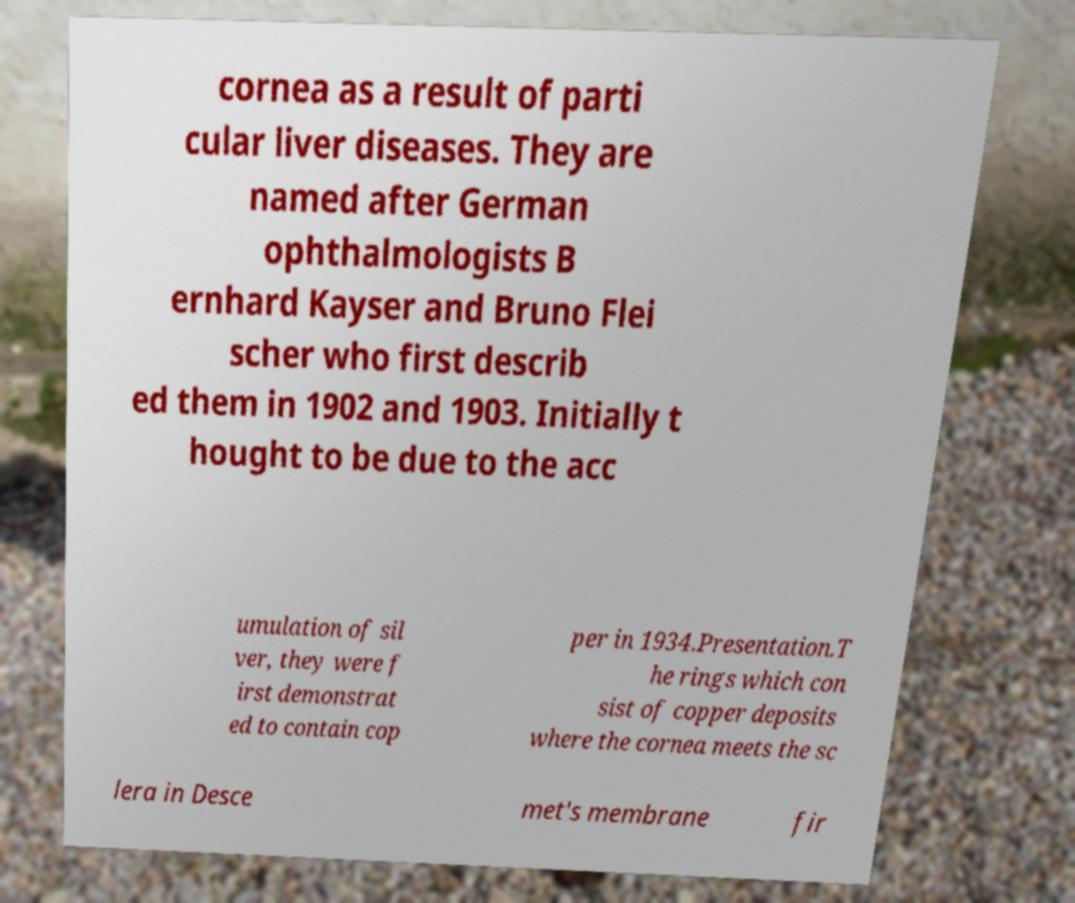Could you assist in decoding the text presented in this image and type it out clearly? cornea as a result of parti cular liver diseases. They are named after German ophthalmologists B ernhard Kayser and Bruno Flei scher who first describ ed them in 1902 and 1903. Initially t hought to be due to the acc umulation of sil ver, they were f irst demonstrat ed to contain cop per in 1934.Presentation.T he rings which con sist of copper deposits where the cornea meets the sc lera in Desce met's membrane fir 